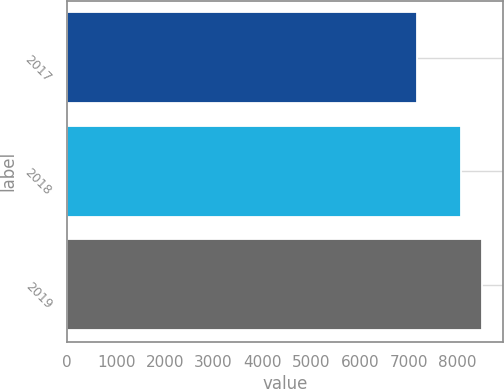Convert chart to OTSL. <chart><loc_0><loc_0><loc_500><loc_500><bar_chart><fcel>2017<fcel>2018<fcel>2019<nl><fcel>7170.2<fcel>8080.1<fcel>8510.4<nl></chart> 